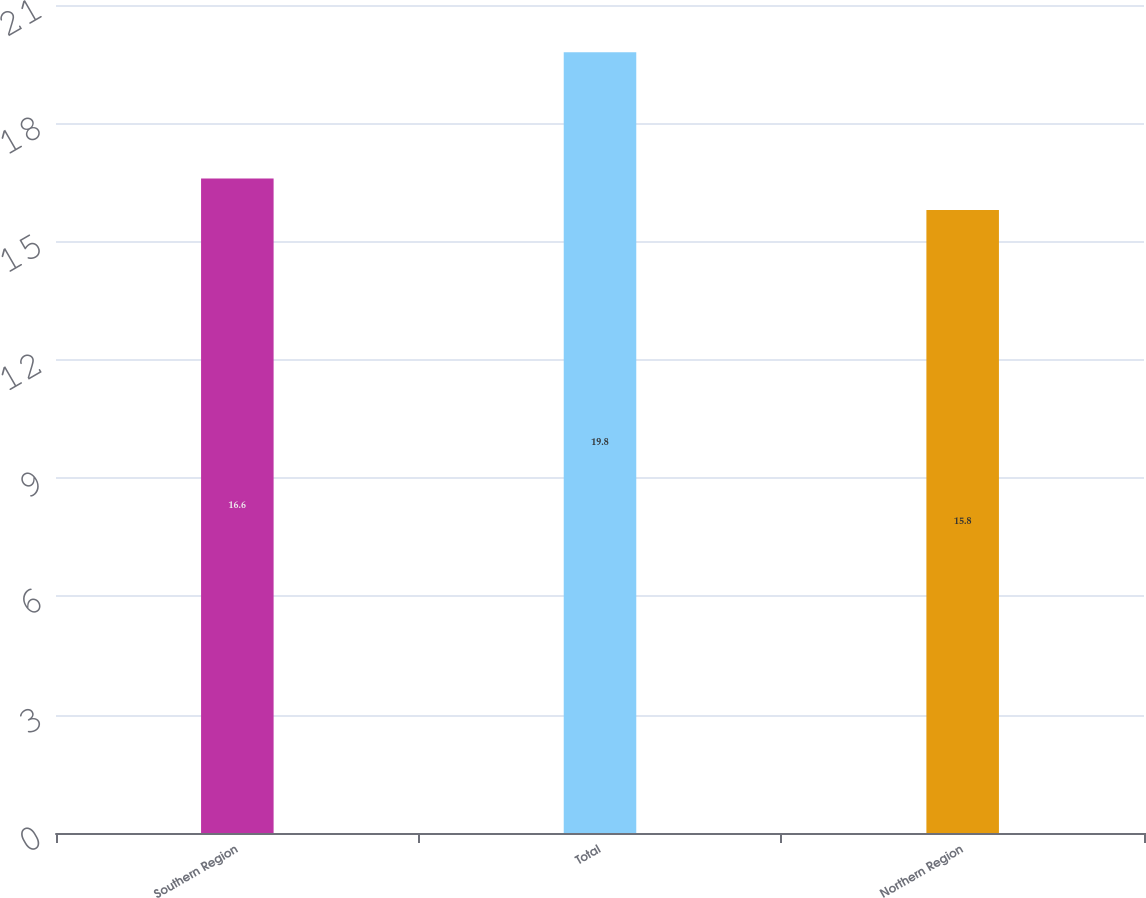Convert chart to OTSL. <chart><loc_0><loc_0><loc_500><loc_500><bar_chart><fcel>Southern Region<fcel>Total<fcel>Northern Region<nl><fcel>16.6<fcel>19.8<fcel>15.8<nl></chart> 